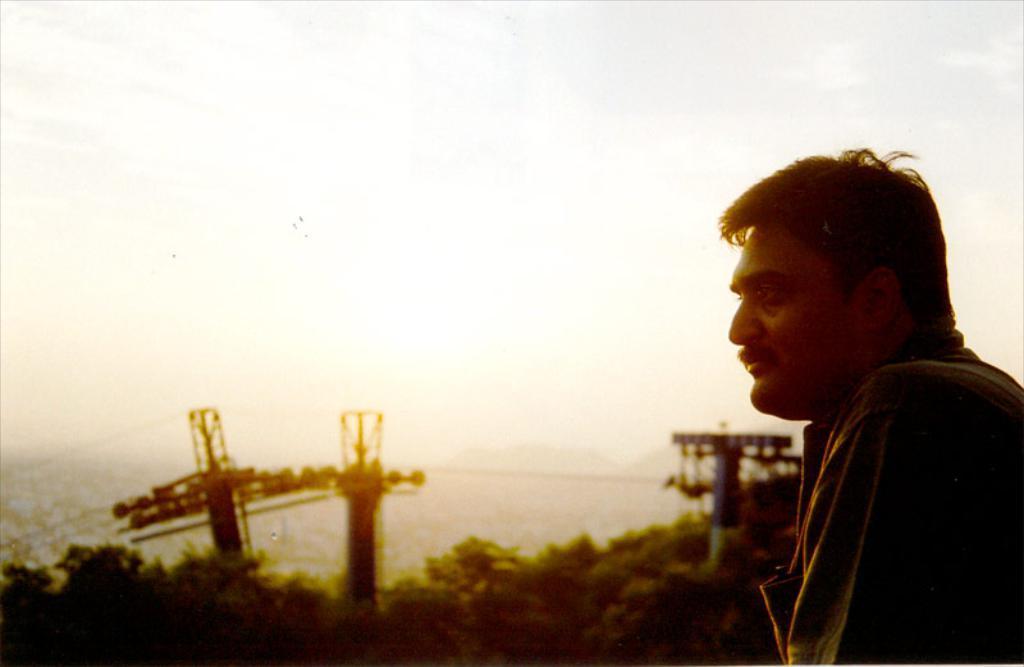Can you describe this image briefly? On the left side of the image we can see one person is standing. In the background, we can see the sky, clouds, trees, pole type structures, wires and a few other objects. 